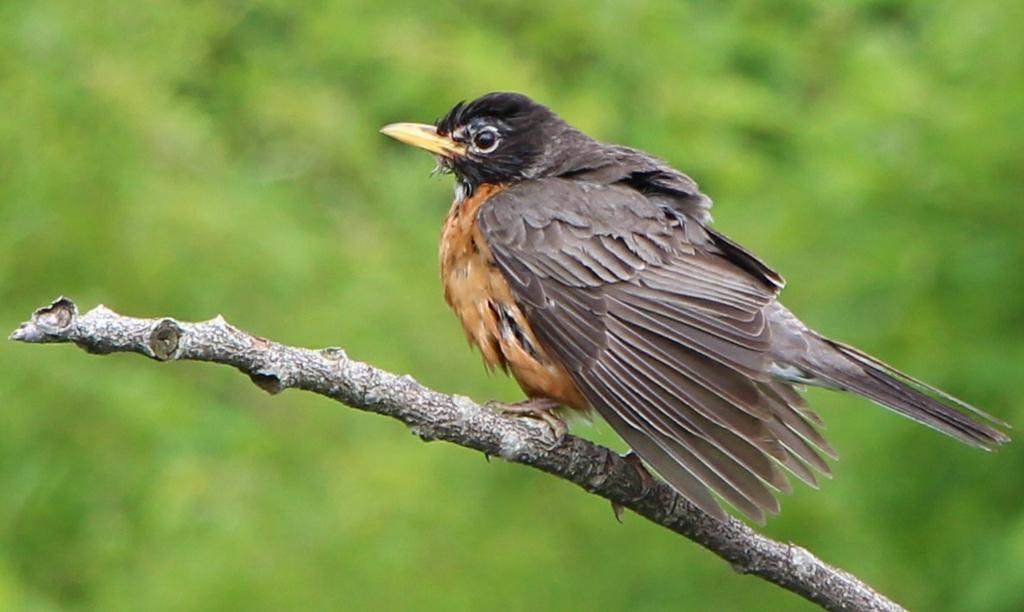In one or two sentences, can you explain what this image depicts? There is a bird on stem. Background it is green. 